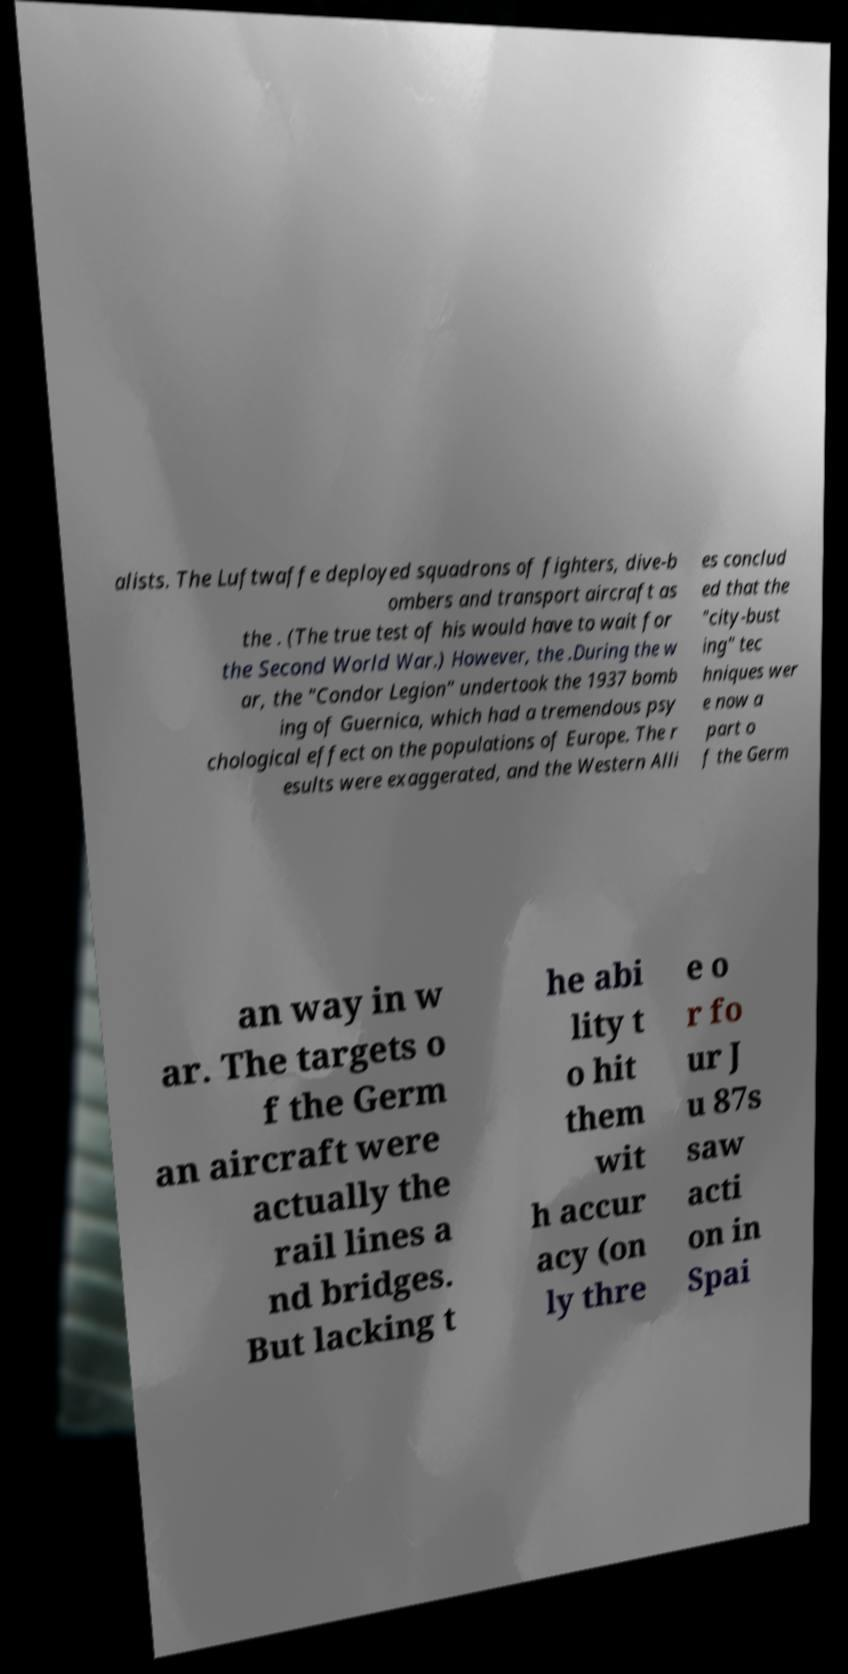Please identify and transcribe the text found in this image. alists. The Luftwaffe deployed squadrons of fighters, dive-b ombers and transport aircraft as the . (The true test of his would have to wait for the Second World War.) However, the .During the w ar, the "Condor Legion" undertook the 1937 bomb ing of Guernica, which had a tremendous psy chological effect on the populations of Europe. The r esults were exaggerated, and the Western Alli es conclud ed that the "city-bust ing" tec hniques wer e now a part o f the Germ an way in w ar. The targets o f the Germ an aircraft were actually the rail lines a nd bridges. But lacking t he abi lity t o hit them wit h accur acy (on ly thre e o r fo ur J u 87s saw acti on in Spai 